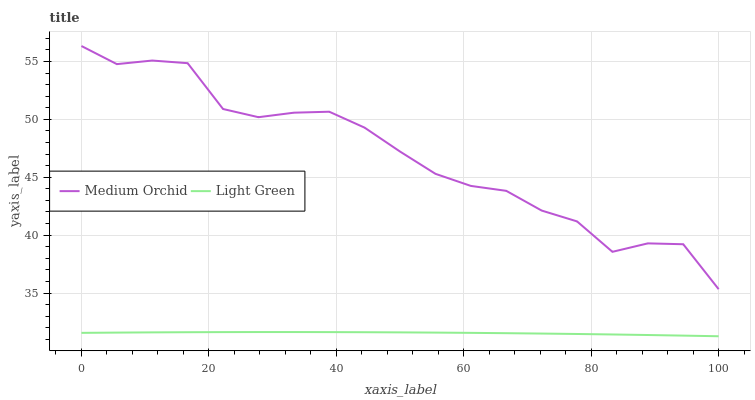Does Light Green have the maximum area under the curve?
Answer yes or no. No. Is Light Green the roughest?
Answer yes or no. No. Does Light Green have the highest value?
Answer yes or no. No. Is Light Green less than Medium Orchid?
Answer yes or no. Yes. Is Medium Orchid greater than Light Green?
Answer yes or no. Yes. Does Light Green intersect Medium Orchid?
Answer yes or no. No. 